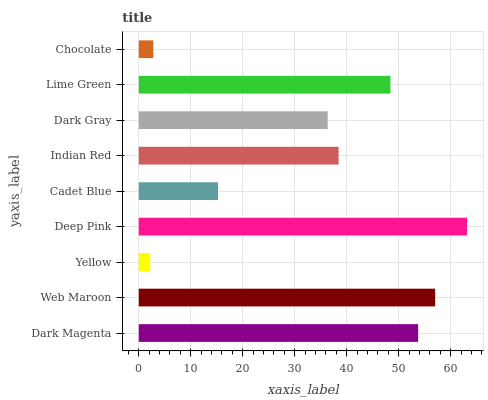Is Yellow the minimum?
Answer yes or no. Yes. Is Deep Pink the maximum?
Answer yes or no. Yes. Is Web Maroon the minimum?
Answer yes or no. No. Is Web Maroon the maximum?
Answer yes or no. No. Is Web Maroon greater than Dark Magenta?
Answer yes or no. Yes. Is Dark Magenta less than Web Maroon?
Answer yes or no. Yes. Is Dark Magenta greater than Web Maroon?
Answer yes or no. No. Is Web Maroon less than Dark Magenta?
Answer yes or no. No. Is Indian Red the high median?
Answer yes or no. Yes. Is Indian Red the low median?
Answer yes or no. Yes. Is Deep Pink the high median?
Answer yes or no. No. Is Dark Magenta the low median?
Answer yes or no. No. 